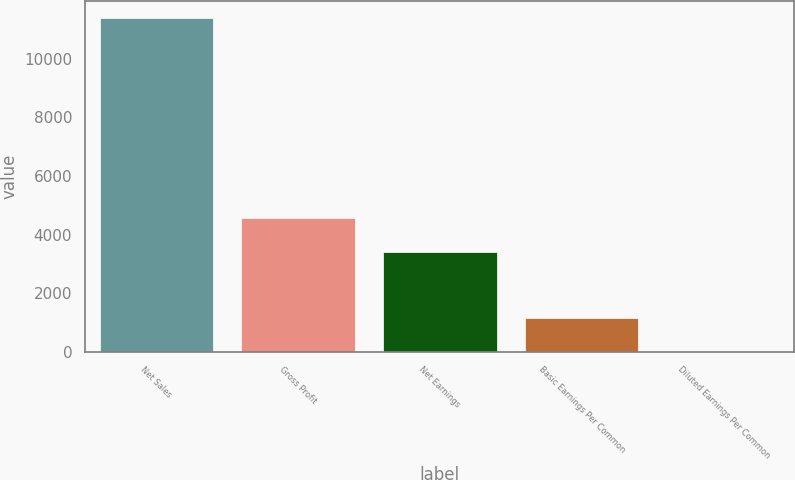<chart> <loc_0><loc_0><loc_500><loc_500><bar_chart><fcel>Net Sales<fcel>Gross Profit<fcel>Net Earnings<fcel>Basic Earnings Per Common<fcel>Diluted Earnings Per Common<nl><fcel>11381<fcel>4552.73<fcel>3414.68<fcel>1138.58<fcel>0.53<nl></chart> 